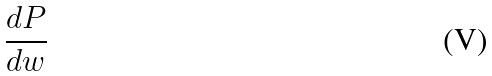Convert formula to latex. <formula><loc_0><loc_0><loc_500><loc_500>\frac { d P } { d w }</formula> 